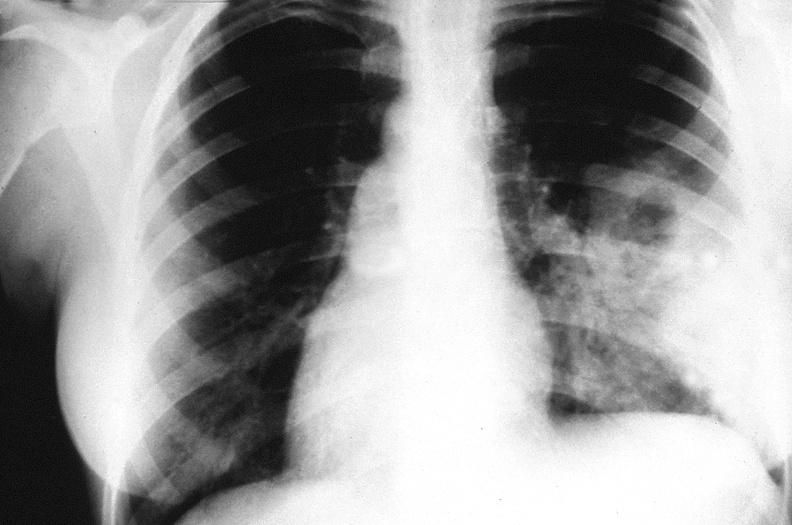s yellow color present?
Answer the question using a single word or phrase. No 